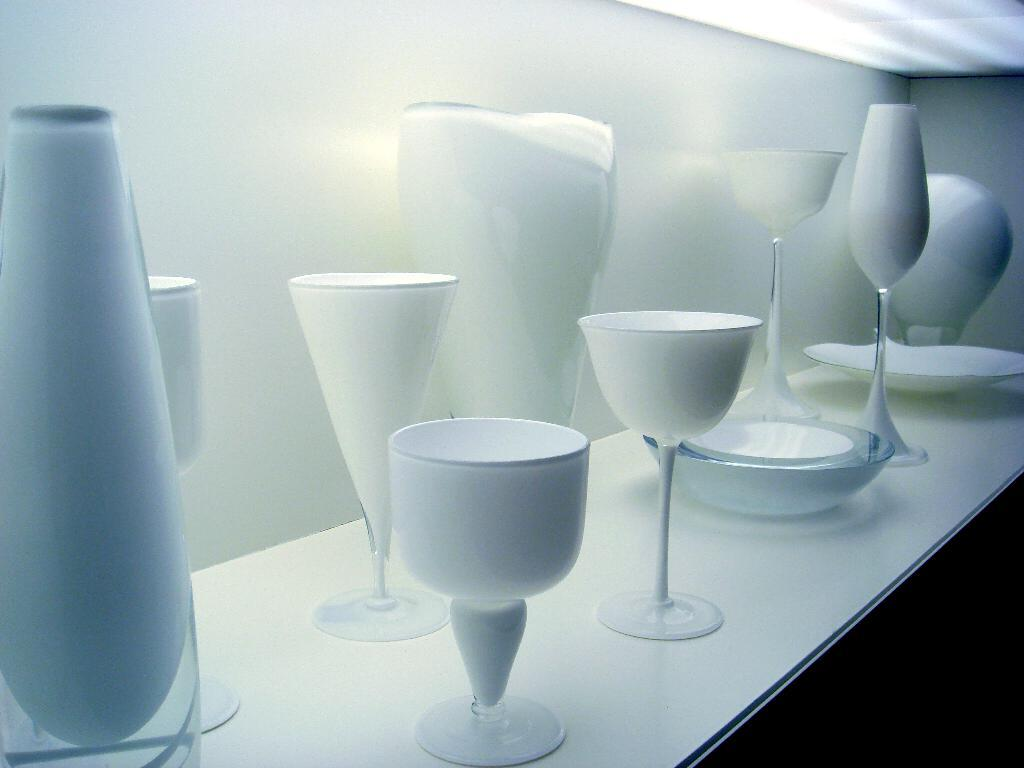What type of tableware can be seen in the image? There are glasses, plates, and bowls in the image. Can you describe the different types of tableware present? The image contains glasses, plates, and bowls. What grade does the cloud in the image represent? There is no cloud present in the image, so it cannot be assigned a grade. Can you describe the playground equipment visible in the image? There is no playground equipment present in the image; it only contains glasses, plates, and bowls. 